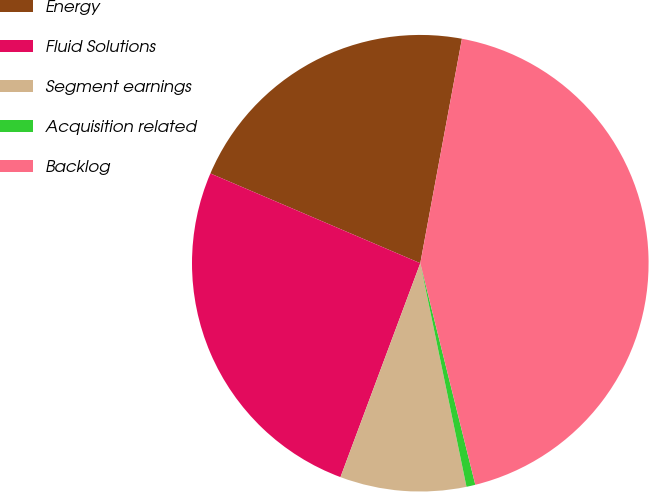<chart> <loc_0><loc_0><loc_500><loc_500><pie_chart><fcel>Energy<fcel>Fluid Solutions<fcel>Segment earnings<fcel>Acquisition related<fcel>Backlog<nl><fcel>21.49%<fcel>25.75%<fcel>8.93%<fcel>0.63%<fcel>43.21%<nl></chart> 